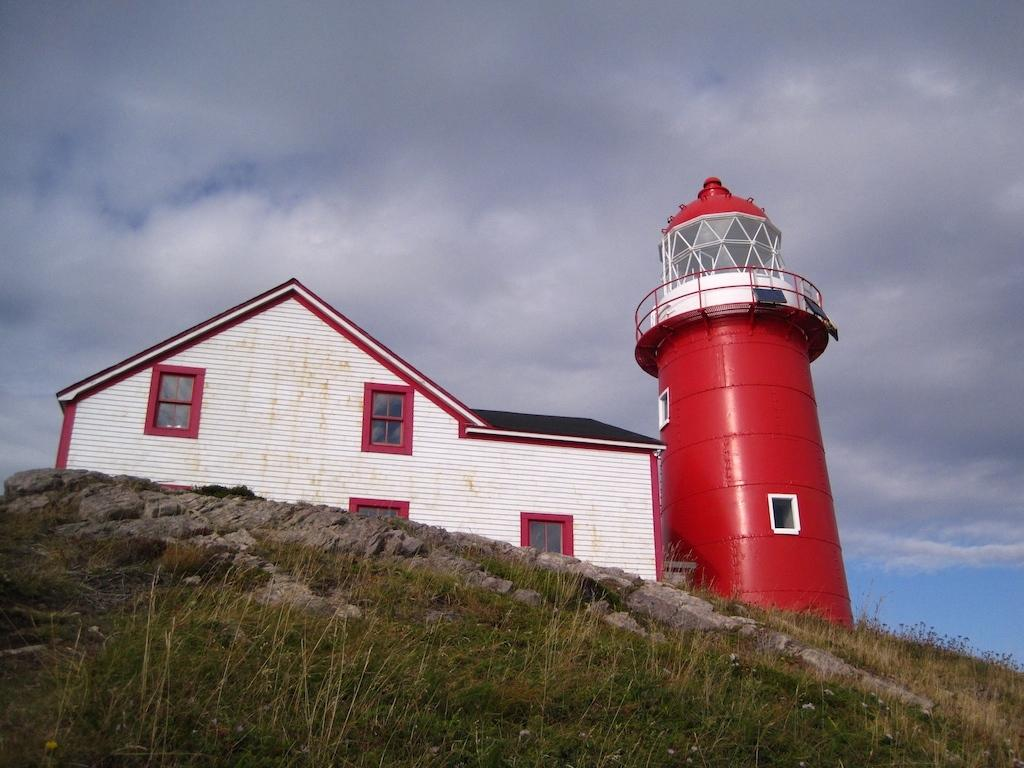What can be seen in the background of the image? The sky is visible in the image. What is present in the sky? There are clouds in the sky. What type of structure is in the image? There is a building in the image. What type of terrain is present in the image? Grass is present on a hill in the image. What type of swimwear is visible on the people in the image? There are no people visible in the image, only the sky, clouds, building, and grass on a hill. What type of observation can be made about the feast in the image? There is no feast present in the image. 